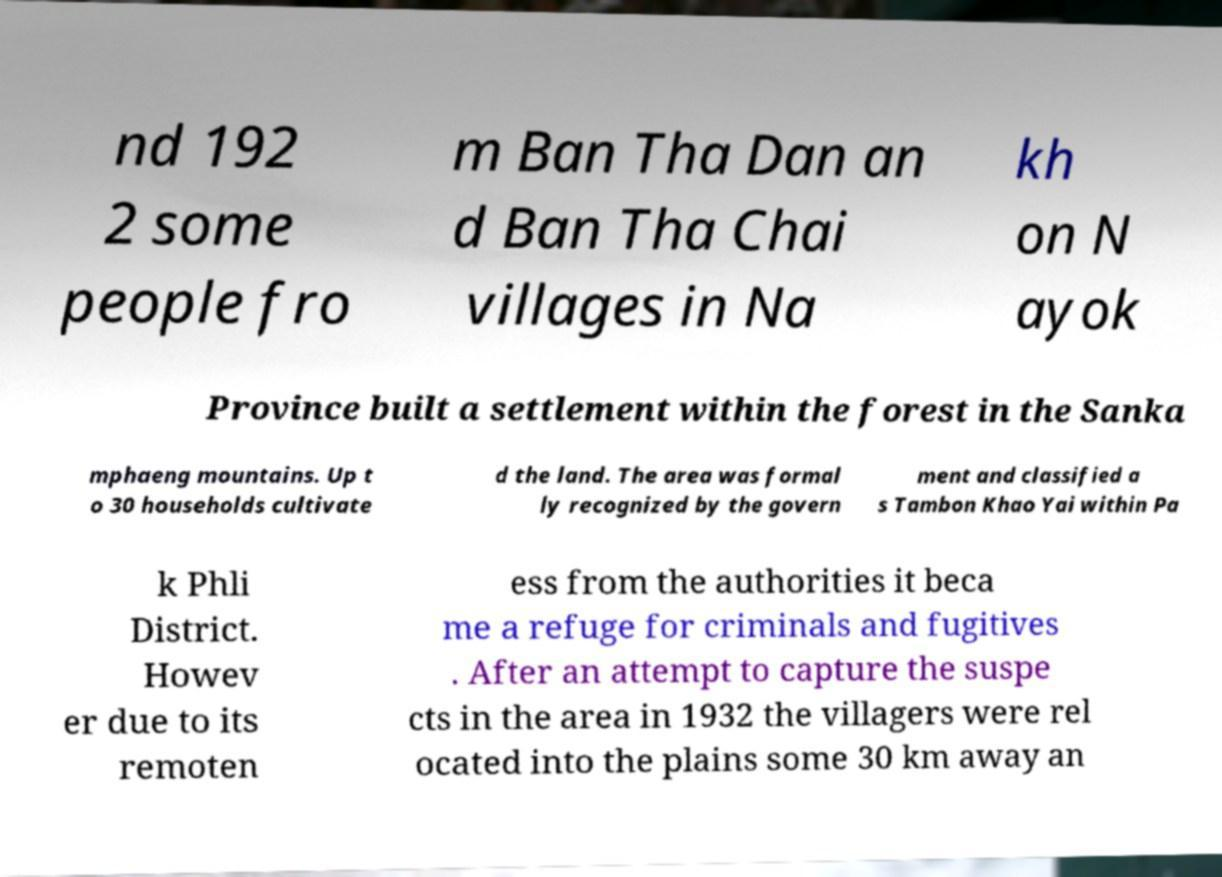For documentation purposes, I need the text within this image transcribed. Could you provide that? nd 192 2 some people fro m Ban Tha Dan an d Ban Tha Chai villages in Na kh on N ayok Province built a settlement within the forest in the Sanka mphaeng mountains. Up t o 30 households cultivate d the land. The area was formal ly recognized by the govern ment and classified a s Tambon Khao Yai within Pa k Phli District. Howev er due to its remoten ess from the authorities it beca me a refuge for criminals and fugitives . After an attempt to capture the suspe cts in the area in 1932 the villagers were rel ocated into the plains some 30 km away an 